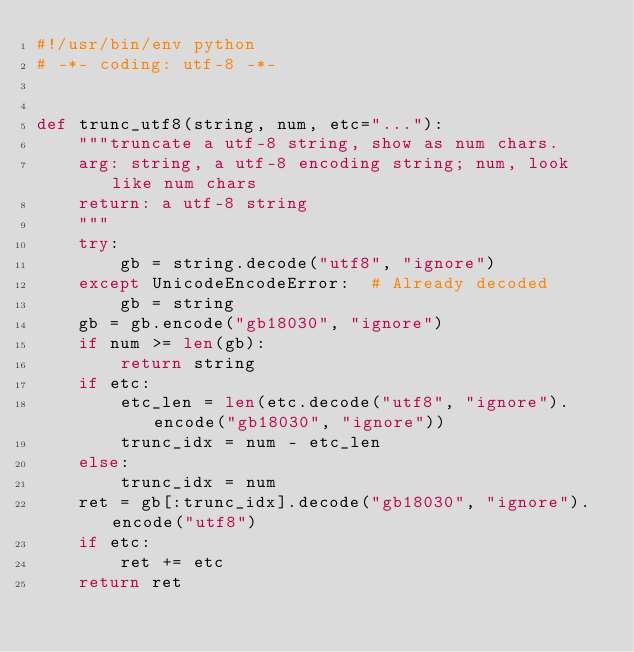<code> <loc_0><loc_0><loc_500><loc_500><_Python_>#!/usr/bin/env python
# -*- coding: utf-8 -*-


def trunc_utf8(string, num, etc="..."):
    """truncate a utf-8 string, show as num chars.
    arg: string, a utf-8 encoding string; num, look like num chars
    return: a utf-8 string
    """
    try:
        gb = string.decode("utf8", "ignore")
    except UnicodeEncodeError:  # Already decoded
        gb = string
    gb = gb.encode("gb18030", "ignore")
    if num >= len(gb):
        return string
    if etc:
        etc_len = len(etc.decode("utf8", "ignore").encode("gb18030", "ignore"))
        trunc_idx = num - etc_len
    else:
        trunc_idx = num
    ret = gb[:trunc_idx].decode("gb18030", "ignore").encode("utf8")
    if etc:
        ret += etc
    return ret
</code> 